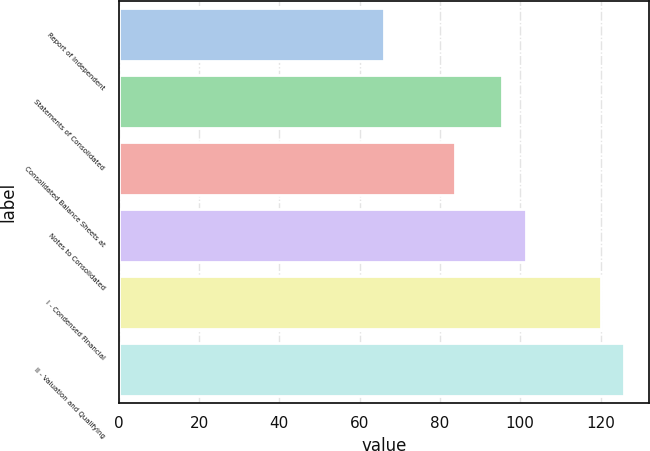<chart> <loc_0><loc_0><loc_500><loc_500><bar_chart><fcel>Report of Independent<fcel>Statements of Consolidated<fcel>Consolidated Balance Sheets at<fcel>Notes to Consolidated<fcel>I - Condensed Financial<fcel>II - Valuation and Qualifying<nl><fcel>66<fcel>95.5<fcel>83.7<fcel>101.4<fcel>120<fcel>125.9<nl></chart> 